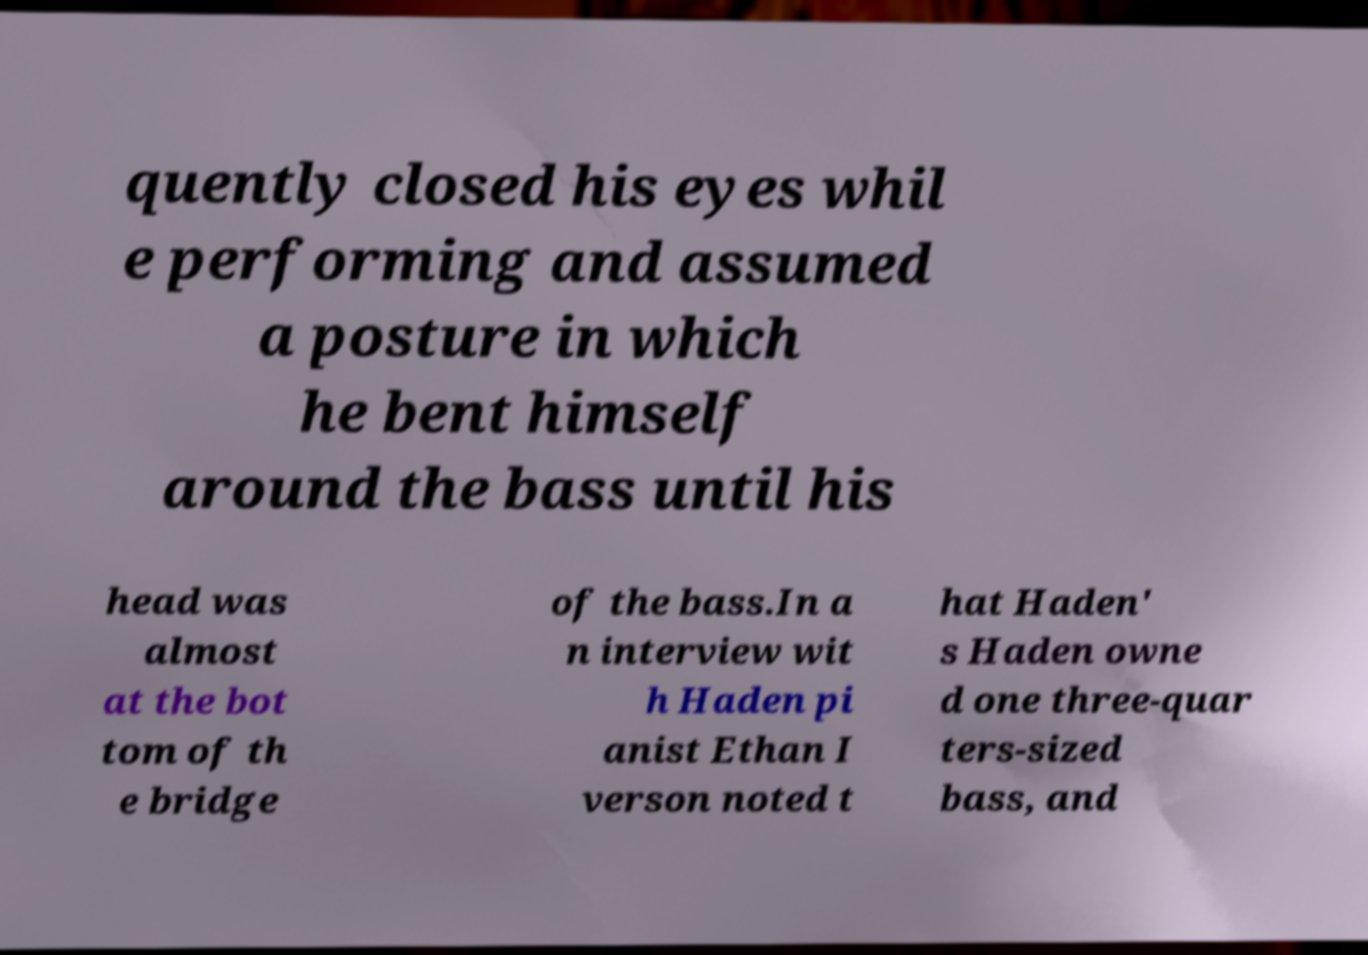Could you assist in decoding the text presented in this image and type it out clearly? quently closed his eyes whil e performing and assumed a posture in which he bent himself around the bass until his head was almost at the bot tom of th e bridge of the bass.In a n interview wit h Haden pi anist Ethan I verson noted t hat Haden' s Haden owne d one three-quar ters-sized bass, and 